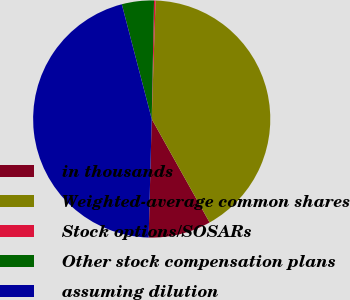<chart> <loc_0><loc_0><loc_500><loc_500><pie_chart><fcel>in thousands<fcel>Weighted-average common shares<fcel>Stock options/SOSARs<fcel>Other stock compensation plans<fcel>assuming dilution<nl><fcel>8.53%<fcel>41.36%<fcel>0.21%<fcel>4.37%<fcel>45.53%<nl></chart> 